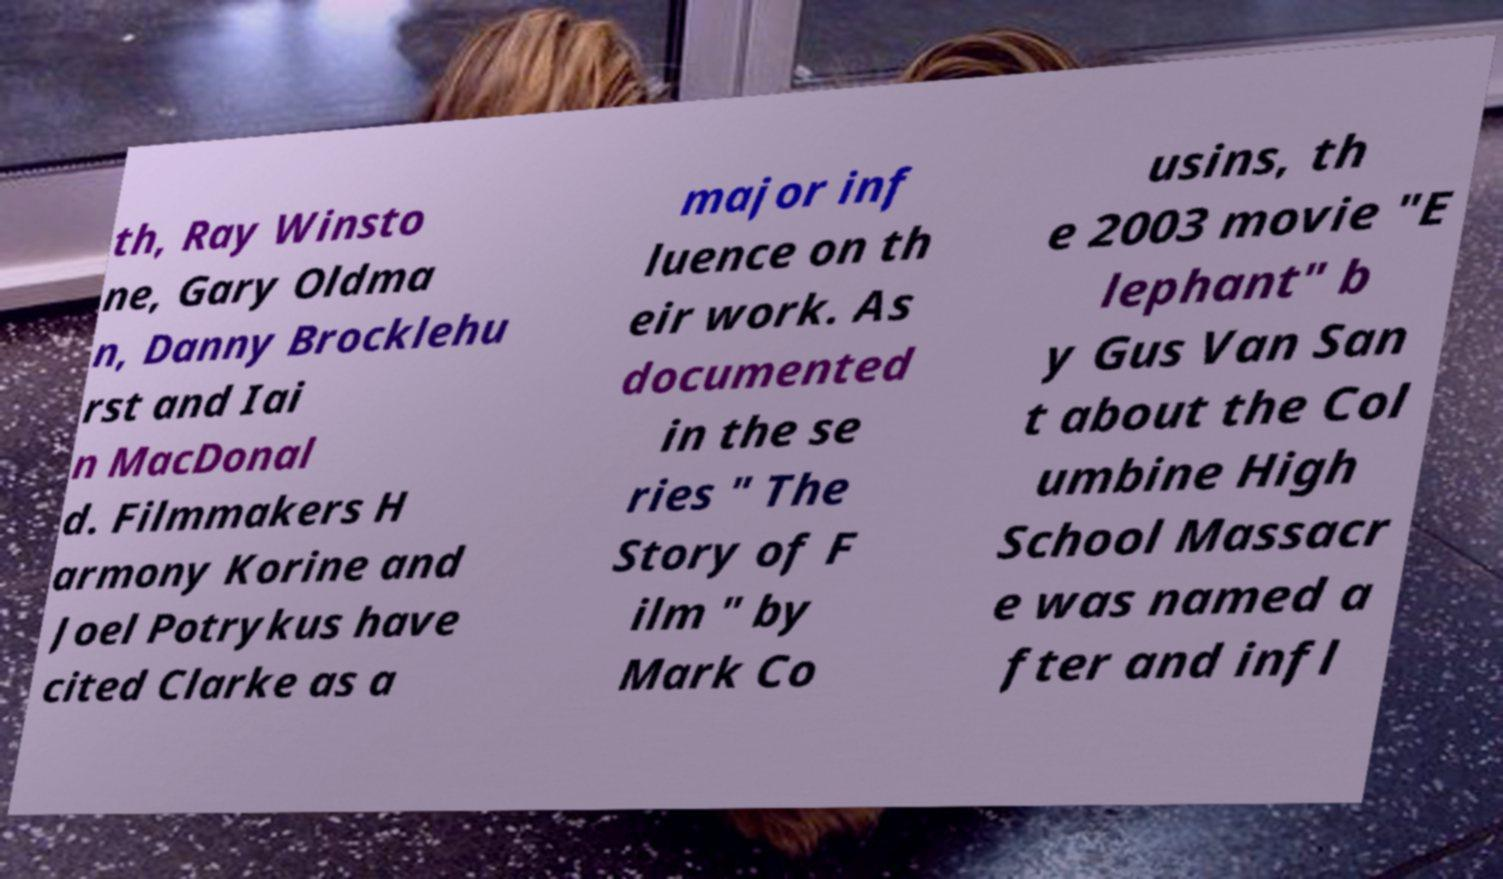Please identify and transcribe the text found in this image. th, Ray Winsto ne, Gary Oldma n, Danny Brocklehu rst and Iai n MacDonal d. Filmmakers H armony Korine and Joel Potrykus have cited Clarke as a major inf luence on th eir work. As documented in the se ries " The Story of F ilm " by Mark Co usins, th e 2003 movie "E lephant" b y Gus Van San t about the Col umbine High School Massacr e was named a fter and infl 